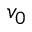<formula> <loc_0><loc_0><loc_500><loc_500>v _ { 0 }</formula> 